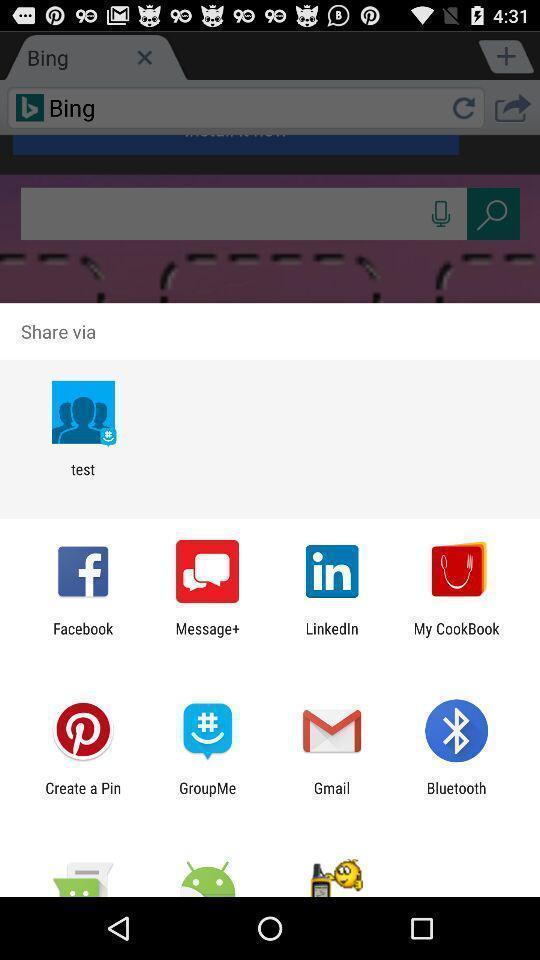Give me a summary of this screen capture. Push up page showing app preference to share. 